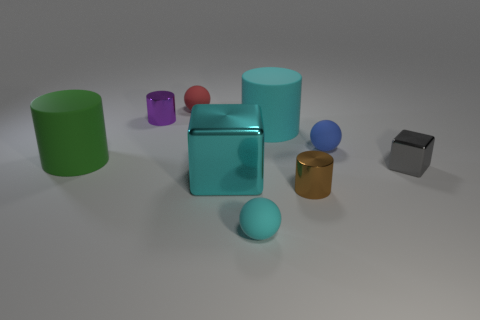How many objects in the image appear to have a metallic finish? There are two objects in the image with a metallic finish. One is a small golden cylinder, and the other appears to be a gray cube with a somewhat reflective surface, indicating a metallic texture. 